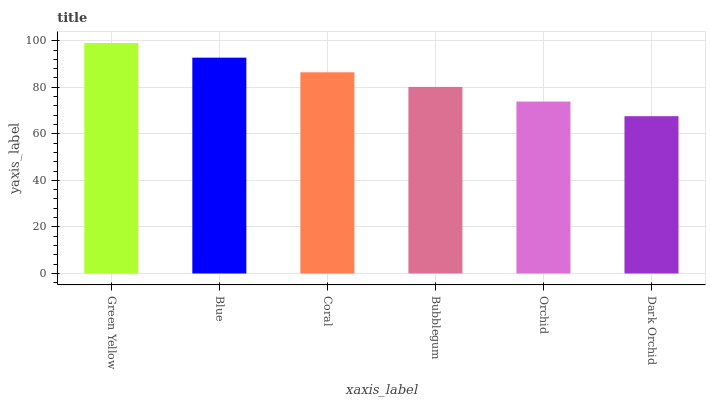Is Dark Orchid the minimum?
Answer yes or no. Yes. Is Green Yellow the maximum?
Answer yes or no. Yes. Is Blue the minimum?
Answer yes or no. No. Is Blue the maximum?
Answer yes or no. No. Is Green Yellow greater than Blue?
Answer yes or no. Yes. Is Blue less than Green Yellow?
Answer yes or no. Yes. Is Blue greater than Green Yellow?
Answer yes or no. No. Is Green Yellow less than Blue?
Answer yes or no. No. Is Coral the high median?
Answer yes or no. Yes. Is Bubblegum the low median?
Answer yes or no. Yes. Is Green Yellow the high median?
Answer yes or no. No. Is Orchid the low median?
Answer yes or no. No. 